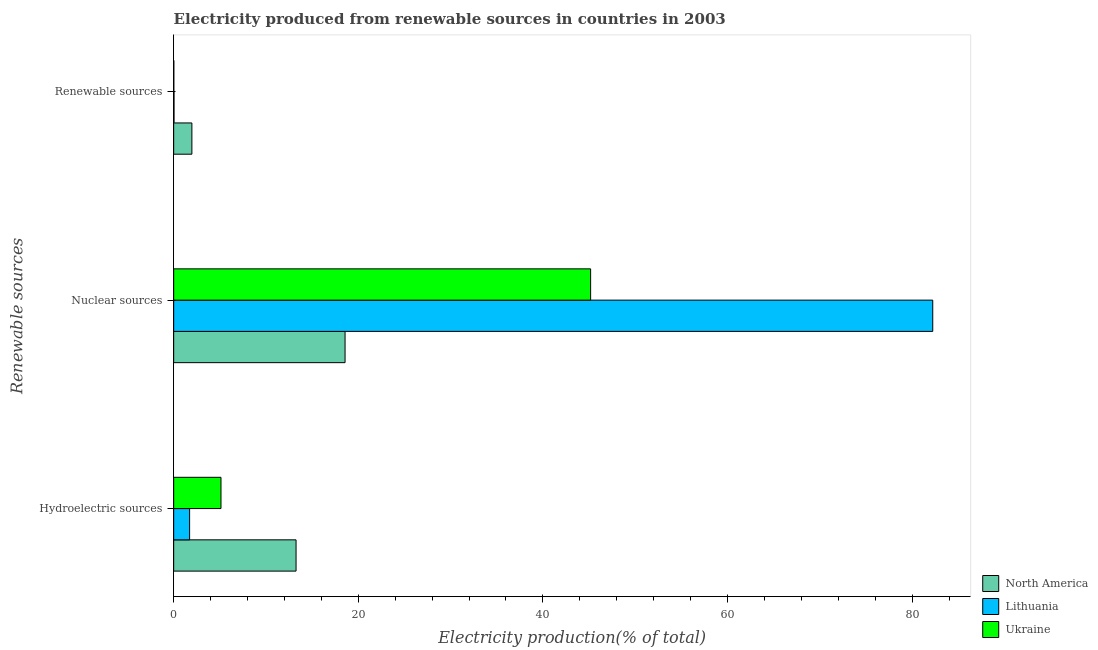Are the number of bars per tick equal to the number of legend labels?
Offer a very short reply. Yes. Are the number of bars on each tick of the Y-axis equal?
Keep it short and to the point. Yes. How many bars are there on the 2nd tick from the top?
Ensure brevity in your answer.  3. What is the label of the 3rd group of bars from the top?
Your answer should be very brief. Hydroelectric sources. What is the percentage of electricity produced by hydroelectric sources in Ukraine?
Provide a short and direct response. 5.13. Across all countries, what is the maximum percentage of electricity produced by hydroelectric sources?
Your answer should be very brief. 13.26. Across all countries, what is the minimum percentage of electricity produced by nuclear sources?
Make the answer very short. 18.57. In which country was the percentage of electricity produced by hydroelectric sources minimum?
Keep it short and to the point. Lithuania. What is the total percentage of electricity produced by renewable sources in the graph?
Keep it short and to the point. 2.03. What is the difference between the percentage of electricity produced by hydroelectric sources in Lithuania and that in Ukraine?
Provide a short and direct response. -3.4. What is the difference between the percentage of electricity produced by hydroelectric sources in North America and the percentage of electricity produced by nuclear sources in Lithuania?
Keep it short and to the point. -68.98. What is the average percentage of electricity produced by nuclear sources per country?
Make the answer very short. 48.66. What is the difference between the percentage of electricity produced by hydroelectric sources and percentage of electricity produced by renewable sources in North America?
Offer a terse response. 11.29. What is the ratio of the percentage of electricity produced by hydroelectric sources in Ukraine to that in Lithuania?
Provide a short and direct response. 2.97. Is the percentage of electricity produced by renewable sources in North America less than that in Ukraine?
Your answer should be compact. No. Is the difference between the percentage of electricity produced by renewable sources in North America and Ukraine greater than the difference between the percentage of electricity produced by hydroelectric sources in North America and Ukraine?
Provide a short and direct response. No. What is the difference between the highest and the second highest percentage of electricity produced by hydroelectric sources?
Keep it short and to the point. 8.13. What is the difference between the highest and the lowest percentage of electricity produced by hydroelectric sources?
Make the answer very short. 11.53. What does the 3rd bar from the top in Hydroelectric sources represents?
Offer a very short reply. North America. What does the 1st bar from the bottom in Nuclear sources represents?
Give a very brief answer. North America. Are all the bars in the graph horizontal?
Your answer should be compact. Yes. How many countries are there in the graph?
Offer a terse response. 3. What is the difference between two consecutive major ticks on the X-axis?
Give a very brief answer. 20. Are the values on the major ticks of X-axis written in scientific E-notation?
Offer a very short reply. No. Does the graph contain any zero values?
Your response must be concise. No. Does the graph contain grids?
Offer a terse response. No. What is the title of the graph?
Provide a short and direct response. Electricity produced from renewable sources in countries in 2003. What is the label or title of the X-axis?
Your response must be concise. Electricity production(% of total). What is the label or title of the Y-axis?
Offer a very short reply. Renewable sources. What is the Electricity production(% of total) in North America in Hydroelectric sources?
Offer a very short reply. 13.26. What is the Electricity production(% of total) of Lithuania in Hydroelectric sources?
Provide a succinct answer. 1.73. What is the Electricity production(% of total) of Ukraine in Hydroelectric sources?
Your response must be concise. 5.13. What is the Electricity production(% of total) in North America in Nuclear sources?
Your answer should be compact. 18.57. What is the Electricity production(% of total) in Lithuania in Nuclear sources?
Make the answer very short. 82.24. What is the Electricity production(% of total) of Ukraine in Nuclear sources?
Offer a terse response. 45.17. What is the Electricity production(% of total) in North America in Renewable sources?
Offer a terse response. 1.97. What is the Electricity production(% of total) in Lithuania in Renewable sources?
Offer a very short reply. 0.04. What is the Electricity production(% of total) in Ukraine in Renewable sources?
Provide a short and direct response. 0.02. Across all Renewable sources, what is the maximum Electricity production(% of total) of North America?
Offer a terse response. 18.57. Across all Renewable sources, what is the maximum Electricity production(% of total) in Lithuania?
Your answer should be compact. 82.24. Across all Renewable sources, what is the maximum Electricity production(% of total) of Ukraine?
Your answer should be very brief. 45.17. Across all Renewable sources, what is the minimum Electricity production(% of total) in North America?
Ensure brevity in your answer.  1.97. Across all Renewable sources, what is the minimum Electricity production(% of total) in Lithuania?
Ensure brevity in your answer.  0.04. Across all Renewable sources, what is the minimum Electricity production(% of total) in Ukraine?
Keep it short and to the point. 0.02. What is the total Electricity production(% of total) in North America in the graph?
Ensure brevity in your answer.  33.8. What is the total Electricity production(% of total) of Lithuania in the graph?
Provide a short and direct response. 84. What is the total Electricity production(% of total) of Ukraine in the graph?
Your answer should be very brief. 50.32. What is the difference between the Electricity production(% of total) of North America in Hydroelectric sources and that in Nuclear sources?
Ensure brevity in your answer.  -5.31. What is the difference between the Electricity production(% of total) in Lithuania in Hydroelectric sources and that in Nuclear sources?
Offer a very short reply. -80.51. What is the difference between the Electricity production(% of total) in Ukraine in Hydroelectric sources and that in Nuclear sources?
Provide a succinct answer. -40.05. What is the difference between the Electricity production(% of total) of North America in Hydroelectric sources and that in Renewable sources?
Make the answer very short. 11.29. What is the difference between the Electricity production(% of total) in Lithuania in Hydroelectric sources and that in Renewable sources?
Offer a very short reply. 1.69. What is the difference between the Electricity production(% of total) in Ukraine in Hydroelectric sources and that in Renewable sources?
Ensure brevity in your answer.  5.11. What is the difference between the Electricity production(% of total) of North America in Nuclear sources and that in Renewable sources?
Make the answer very short. 16.59. What is the difference between the Electricity production(% of total) of Lithuania in Nuclear sources and that in Renewable sources?
Offer a terse response. 82.2. What is the difference between the Electricity production(% of total) in Ukraine in Nuclear sources and that in Renewable sources?
Give a very brief answer. 45.16. What is the difference between the Electricity production(% of total) of North America in Hydroelectric sources and the Electricity production(% of total) of Lithuania in Nuclear sources?
Offer a terse response. -68.98. What is the difference between the Electricity production(% of total) of North America in Hydroelectric sources and the Electricity production(% of total) of Ukraine in Nuclear sources?
Your answer should be compact. -31.91. What is the difference between the Electricity production(% of total) of Lithuania in Hydroelectric sources and the Electricity production(% of total) of Ukraine in Nuclear sources?
Your response must be concise. -43.45. What is the difference between the Electricity production(% of total) in North America in Hydroelectric sources and the Electricity production(% of total) in Lithuania in Renewable sources?
Provide a short and direct response. 13.22. What is the difference between the Electricity production(% of total) of North America in Hydroelectric sources and the Electricity production(% of total) of Ukraine in Renewable sources?
Keep it short and to the point. 13.24. What is the difference between the Electricity production(% of total) in Lithuania in Hydroelectric sources and the Electricity production(% of total) in Ukraine in Renewable sources?
Make the answer very short. 1.71. What is the difference between the Electricity production(% of total) of North America in Nuclear sources and the Electricity production(% of total) of Lithuania in Renewable sources?
Make the answer very short. 18.53. What is the difference between the Electricity production(% of total) in North America in Nuclear sources and the Electricity production(% of total) in Ukraine in Renewable sources?
Your response must be concise. 18.55. What is the difference between the Electricity production(% of total) of Lithuania in Nuclear sources and the Electricity production(% of total) of Ukraine in Renewable sources?
Give a very brief answer. 82.22. What is the average Electricity production(% of total) in North America per Renewable sources?
Make the answer very short. 11.27. What is the average Electricity production(% of total) of Lithuania per Renewable sources?
Offer a terse response. 28. What is the average Electricity production(% of total) in Ukraine per Renewable sources?
Your answer should be very brief. 16.77. What is the difference between the Electricity production(% of total) in North America and Electricity production(% of total) in Lithuania in Hydroelectric sources?
Provide a succinct answer. 11.53. What is the difference between the Electricity production(% of total) in North America and Electricity production(% of total) in Ukraine in Hydroelectric sources?
Ensure brevity in your answer.  8.13. What is the difference between the Electricity production(% of total) in Lithuania and Electricity production(% of total) in Ukraine in Hydroelectric sources?
Your response must be concise. -3.4. What is the difference between the Electricity production(% of total) in North America and Electricity production(% of total) in Lithuania in Nuclear sources?
Provide a succinct answer. -63.67. What is the difference between the Electricity production(% of total) of North America and Electricity production(% of total) of Ukraine in Nuclear sources?
Make the answer very short. -26.61. What is the difference between the Electricity production(% of total) of Lithuania and Electricity production(% of total) of Ukraine in Nuclear sources?
Provide a short and direct response. 37.07. What is the difference between the Electricity production(% of total) in North America and Electricity production(% of total) in Lithuania in Renewable sources?
Provide a short and direct response. 1.94. What is the difference between the Electricity production(% of total) in North America and Electricity production(% of total) in Ukraine in Renewable sources?
Offer a terse response. 1.96. What is the ratio of the Electricity production(% of total) of North America in Hydroelectric sources to that in Nuclear sources?
Give a very brief answer. 0.71. What is the ratio of the Electricity production(% of total) of Lithuania in Hydroelectric sources to that in Nuclear sources?
Provide a succinct answer. 0.02. What is the ratio of the Electricity production(% of total) of Ukraine in Hydroelectric sources to that in Nuclear sources?
Your answer should be compact. 0.11. What is the ratio of the Electricity production(% of total) of North America in Hydroelectric sources to that in Renewable sources?
Keep it short and to the point. 6.72. What is the ratio of the Electricity production(% of total) in Lithuania in Hydroelectric sources to that in Renewable sources?
Your answer should be compact. 46.43. What is the ratio of the Electricity production(% of total) of Ukraine in Hydroelectric sources to that in Renewable sources?
Your response must be concise. 298. What is the ratio of the Electricity production(% of total) in North America in Nuclear sources to that in Renewable sources?
Offer a very short reply. 9.41. What is the ratio of the Electricity production(% of total) of Lithuania in Nuclear sources to that in Renewable sources?
Your response must be concise. 2212. What is the ratio of the Electricity production(% of total) in Ukraine in Nuclear sources to that in Renewable sources?
Provide a succinct answer. 2626. What is the difference between the highest and the second highest Electricity production(% of total) in North America?
Give a very brief answer. 5.31. What is the difference between the highest and the second highest Electricity production(% of total) in Lithuania?
Your answer should be very brief. 80.51. What is the difference between the highest and the second highest Electricity production(% of total) of Ukraine?
Keep it short and to the point. 40.05. What is the difference between the highest and the lowest Electricity production(% of total) of North America?
Provide a succinct answer. 16.59. What is the difference between the highest and the lowest Electricity production(% of total) in Lithuania?
Provide a succinct answer. 82.2. What is the difference between the highest and the lowest Electricity production(% of total) of Ukraine?
Provide a short and direct response. 45.16. 